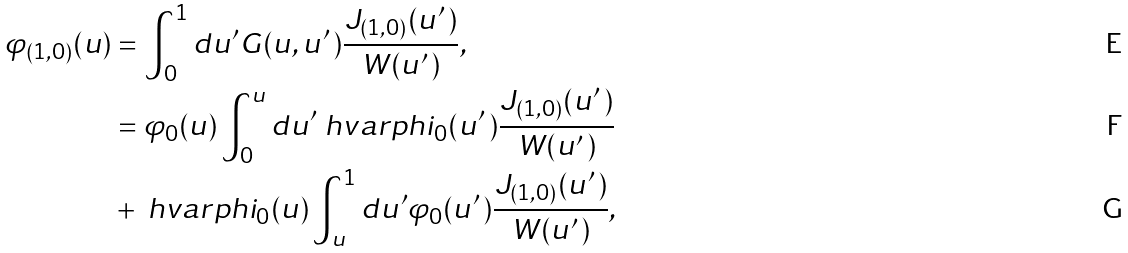Convert formula to latex. <formula><loc_0><loc_0><loc_500><loc_500>\varphi _ { ( 1 , 0 ) } ( u ) & = \int ^ { 1 } _ { 0 } d u ^ { \prime } G ( u , u ^ { \prime } \, ) \frac { J _ { ( 1 , 0 ) } ( u ^ { \prime } \, ) } { W ( u ^ { \prime } \, ) } , \\ & = \varphi _ { 0 } ( u ) \int ^ { u } _ { 0 } d u ^ { \prime } \ h v a r p h i _ { 0 } ( u ^ { \prime } \, ) \frac { J _ { ( 1 , 0 ) } ( u ^ { \prime } \, ) } { W ( u ^ { \prime } \, ) } \\ & + \ h v a r p h i _ { 0 } ( u ) \int ^ { 1 } _ { u } d u ^ { \prime } \varphi _ { 0 } ( u ^ { \prime } \, ) \frac { J _ { ( 1 , 0 ) } ( u ^ { \prime } \, ) } { W ( u ^ { \prime } \, ) } ,</formula> 